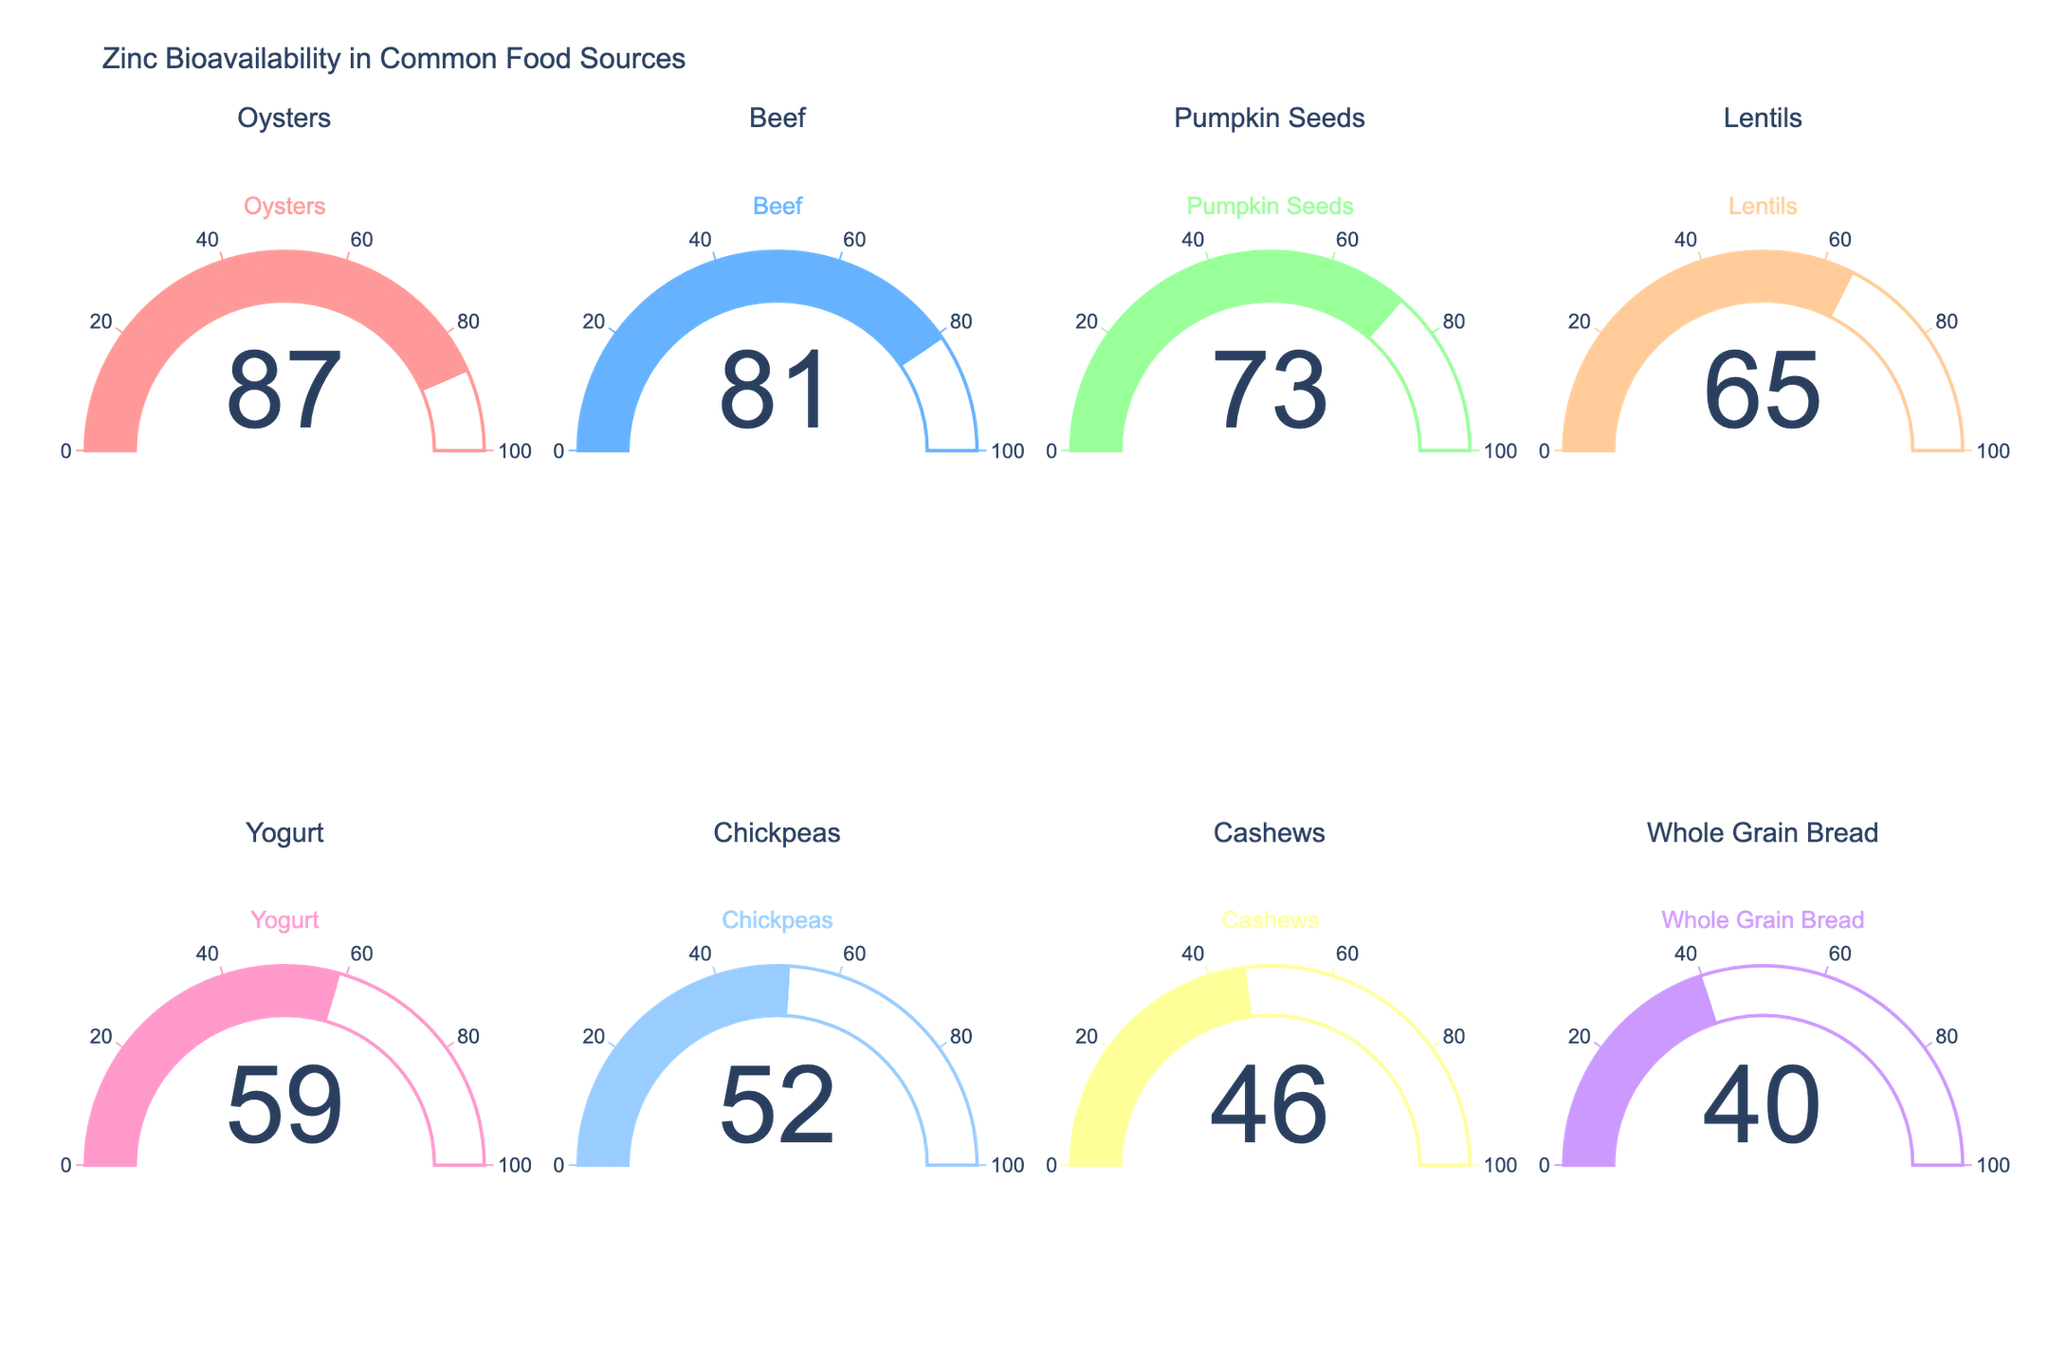How many food sources are displayed in the figure? Count the number of gauges shown in the figure. Each gauge represents a different food source.
Answer: 8 What is the zinc bioavailability in beef? Look at the gauge labeled "Beef" and note the value displayed on the gauge.
Answer: 81% Which food source has the highest zinc bioavailability? Identify the gauge with the highest displayed value.
Answer: Oysters What is the difference in zinc bioavailability between lentils and chickpeas? Identify the values for lentils and chickpeas from their respective gauges and subtract the smaller value from the larger value (Lentils: 65%, Chickpeas: 52%). 65 - 52 = 13.
Answer: 13% What is the average zinc bioavailability among the foods displayed? Sum the bioavailability percentages of all food sources and divide by the number of food sources. (87+81+73+65+59+52+46+40)/8 = 503/8 = 62.875
Answer: 62.875% Which food source has the lowest zinc bioavailability? Identify the gauge with the lowest displayed value.
Answer: Whole Grain Bread Which food sources have a zinc bioavailability greater than 70%? List the food sources whose gauges display values greater than 70%.
Answer: Oysters, Beef, Pumpkin Seeds Is the zinc bioavailability of yogurt closer to lentils or chickpeas? Identify the zinc bioavailability of yogurt, lentils, and chickpeas (Yogurt: 59%, Lentils: 65%, Chickpeas: 52%). Determine the differences: 59 - 52 = 7 and 65 - 59 = 6.
Answer: Lentils What percentage of food sources have a zinc bioavailability less than 60%? Count the number of food sources with zinc bioavailability under 60%, then divide by the total number of food sources and multiply by 100. ((52+46+40)/8) x 100 = (3/8) x 100 = 37.5%
Answer: 37.5% Which food has a zinc bioavailability exactly halfway between the highest and lowest values? Highest: 87%, Lowest: 40%, Midpoint: (87+40)/2 = 63.5%. Identify the food source with the closest bioavailability to this midpoint.
Answer: Lentils 